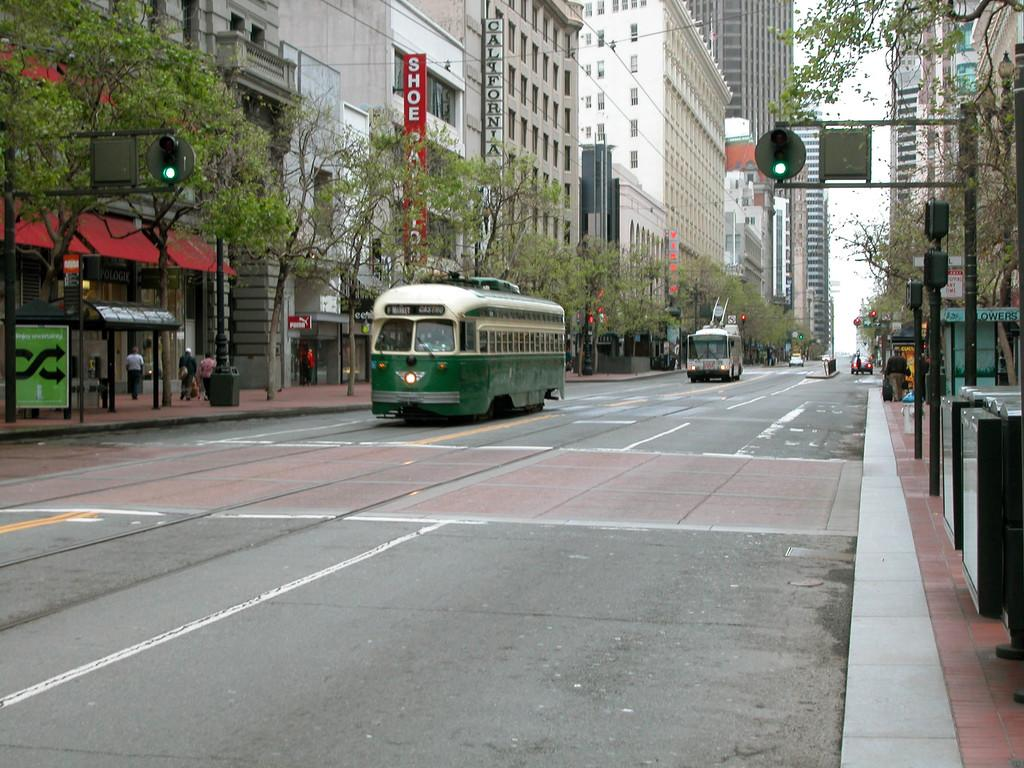What can be seen on the road in the image? There are vehicles on the road in the image. What type of natural elements are present in the image? There are trees in the image. What structures can be seen in the image? There are poles, boards, and buildings in the image. Are there any people visible in the image? Yes, there are persons in the image. What is visible in the background of the image? The sky is visible in the background of the image. What type of appliance is being used by the persons in the image? There is no appliance visible in the image; it features vehicles, trees, poles, boards, buildings, persons, and the sky. Can you describe the romantic interaction between the persons in the image? There is no romantic interaction, such as a kiss, depicted in the image. 